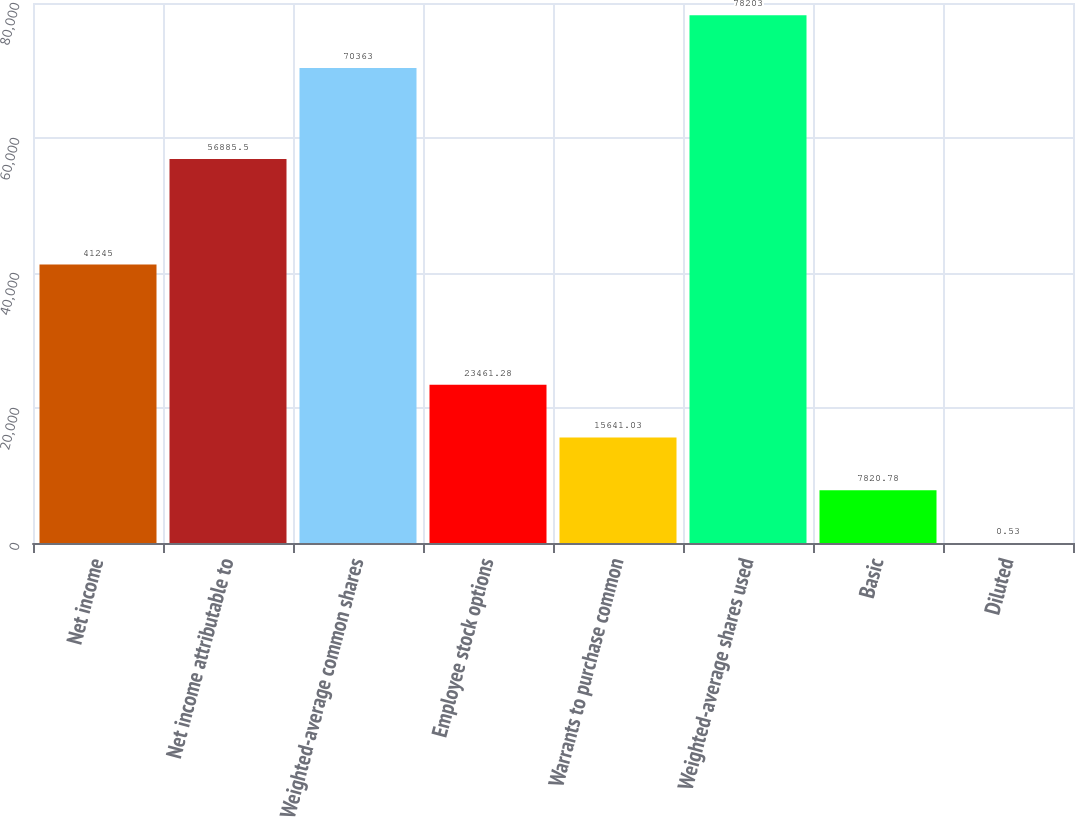Convert chart. <chart><loc_0><loc_0><loc_500><loc_500><bar_chart><fcel>Net income<fcel>Net income attributable to<fcel>Weighted-average common shares<fcel>Employee stock options<fcel>Warrants to purchase common<fcel>Weighted-average shares used<fcel>Basic<fcel>Diluted<nl><fcel>41245<fcel>56885.5<fcel>70363<fcel>23461.3<fcel>15641<fcel>78203<fcel>7820.78<fcel>0.53<nl></chart> 